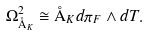Convert formula to latex. <formula><loc_0><loc_0><loc_500><loc_500>\Omega ^ { 2 } _ { \AA _ { K } } \cong \AA _ { K } d \pi _ { F } \wedge d T .</formula> 